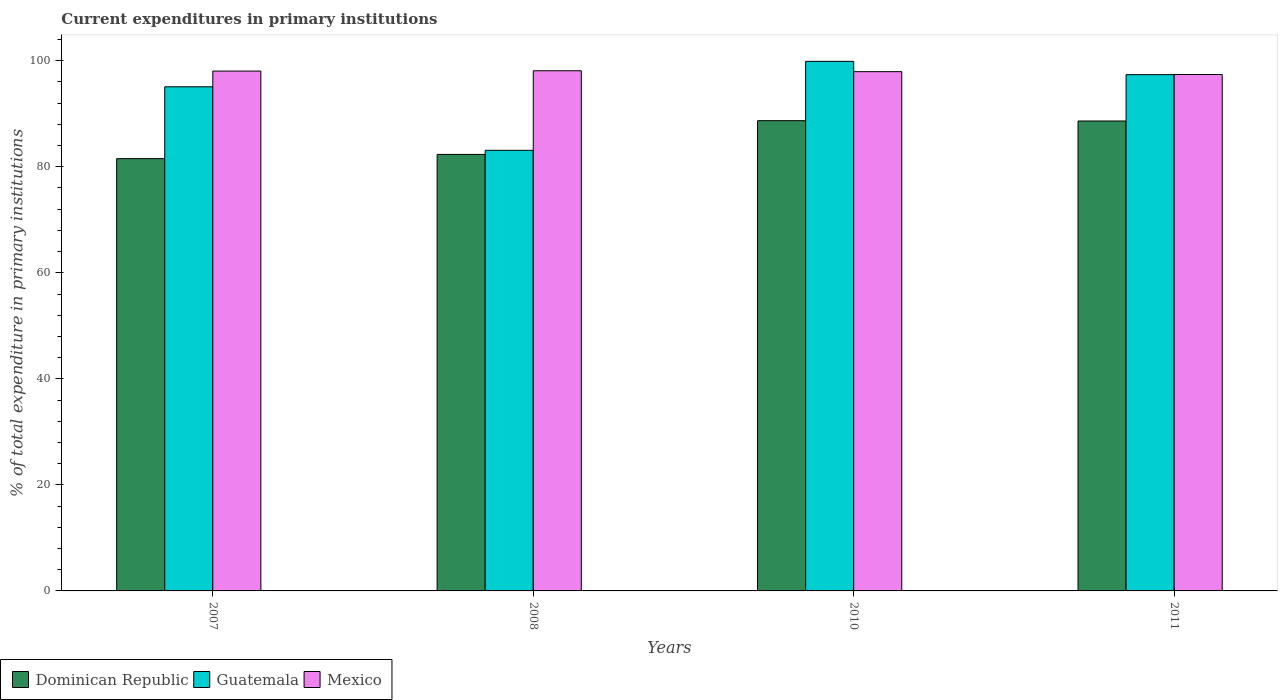How many different coloured bars are there?
Provide a short and direct response. 3. How many groups of bars are there?
Your answer should be very brief. 4. How many bars are there on the 1st tick from the left?
Provide a short and direct response. 3. What is the current expenditures in primary institutions in Guatemala in 2007?
Offer a terse response. 95.09. Across all years, what is the maximum current expenditures in primary institutions in Mexico?
Your answer should be compact. 98.11. Across all years, what is the minimum current expenditures in primary institutions in Mexico?
Keep it short and to the point. 97.4. In which year was the current expenditures in primary institutions in Dominican Republic maximum?
Provide a short and direct response. 2010. What is the total current expenditures in primary institutions in Guatemala in the graph?
Ensure brevity in your answer.  375.46. What is the difference between the current expenditures in primary institutions in Dominican Republic in 2008 and that in 2010?
Ensure brevity in your answer.  -6.36. What is the difference between the current expenditures in primary institutions in Mexico in 2007 and the current expenditures in primary institutions in Guatemala in 2010?
Ensure brevity in your answer.  -1.83. What is the average current expenditures in primary institutions in Dominican Republic per year?
Provide a short and direct response. 85.3. In the year 2008, what is the difference between the current expenditures in primary institutions in Mexico and current expenditures in primary institutions in Dominican Republic?
Make the answer very short. 15.78. In how many years, is the current expenditures in primary institutions in Dominican Republic greater than 76 %?
Provide a succinct answer. 4. What is the ratio of the current expenditures in primary institutions in Mexico in 2010 to that in 2011?
Your response must be concise. 1.01. Is the current expenditures in primary institutions in Guatemala in 2007 less than that in 2008?
Your answer should be compact. No. Is the difference between the current expenditures in primary institutions in Mexico in 2007 and 2011 greater than the difference between the current expenditures in primary institutions in Dominican Republic in 2007 and 2011?
Your answer should be compact. Yes. What is the difference between the highest and the second highest current expenditures in primary institutions in Guatemala?
Provide a short and direct response. 2.51. What is the difference between the highest and the lowest current expenditures in primary institutions in Dominican Republic?
Offer a terse response. 7.16. Is the sum of the current expenditures in primary institutions in Guatemala in 2007 and 2008 greater than the maximum current expenditures in primary institutions in Dominican Republic across all years?
Make the answer very short. Yes. What does the 1st bar from the left in 2008 represents?
Ensure brevity in your answer.  Dominican Republic. What does the 3rd bar from the right in 2011 represents?
Your answer should be very brief. Dominican Republic. Are all the bars in the graph horizontal?
Keep it short and to the point. No. How many years are there in the graph?
Provide a short and direct response. 4. Are the values on the major ticks of Y-axis written in scientific E-notation?
Offer a very short reply. No. Where does the legend appear in the graph?
Ensure brevity in your answer.  Bottom left. How are the legend labels stacked?
Give a very brief answer. Horizontal. What is the title of the graph?
Offer a terse response. Current expenditures in primary institutions. Does "Equatorial Guinea" appear as one of the legend labels in the graph?
Provide a succinct answer. No. What is the label or title of the Y-axis?
Provide a short and direct response. % of total expenditure in primary institutions. What is the % of total expenditure in primary institutions in Dominican Republic in 2007?
Your answer should be compact. 81.54. What is the % of total expenditure in primary institutions of Guatemala in 2007?
Make the answer very short. 95.09. What is the % of total expenditure in primary institutions of Mexico in 2007?
Give a very brief answer. 98.05. What is the % of total expenditure in primary institutions of Dominican Republic in 2008?
Provide a succinct answer. 82.33. What is the % of total expenditure in primary institutions in Guatemala in 2008?
Offer a very short reply. 83.11. What is the % of total expenditure in primary institutions of Mexico in 2008?
Your answer should be very brief. 98.11. What is the % of total expenditure in primary institutions in Dominican Republic in 2010?
Offer a terse response. 88.69. What is the % of total expenditure in primary institutions in Guatemala in 2010?
Ensure brevity in your answer.  99.89. What is the % of total expenditure in primary institutions in Mexico in 2010?
Your response must be concise. 97.94. What is the % of total expenditure in primary institutions in Dominican Republic in 2011?
Provide a succinct answer. 88.63. What is the % of total expenditure in primary institutions in Guatemala in 2011?
Your response must be concise. 97.38. What is the % of total expenditure in primary institutions in Mexico in 2011?
Your response must be concise. 97.4. Across all years, what is the maximum % of total expenditure in primary institutions of Dominican Republic?
Offer a very short reply. 88.69. Across all years, what is the maximum % of total expenditure in primary institutions in Guatemala?
Your answer should be very brief. 99.89. Across all years, what is the maximum % of total expenditure in primary institutions of Mexico?
Make the answer very short. 98.11. Across all years, what is the minimum % of total expenditure in primary institutions of Dominican Republic?
Your answer should be very brief. 81.54. Across all years, what is the minimum % of total expenditure in primary institutions of Guatemala?
Offer a very short reply. 83.11. Across all years, what is the minimum % of total expenditure in primary institutions in Mexico?
Offer a very short reply. 97.4. What is the total % of total expenditure in primary institutions in Dominican Republic in the graph?
Make the answer very short. 341.2. What is the total % of total expenditure in primary institutions of Guatemala in the graph?
Offer a very short reply. 375.46. What is the total % of total expenditure in primary institutions of Mexico in the graph?
Offer a terse response. 391.51. What is the difference between the % of total expenditure in primary institutions in Dominican Republic in 2007 and that in 2008?
Ensure brevity in your answer.  -0.8. What is the difference between the % of total expenditure in primary institutions of Guatemala in 2007 and that in 2008?
Your answer should be very brief. 11.98. What is the difference between the % of total expenditure in primary institutions in Mexico in 2007 and that in 2008?
Ensure brevity in your answer.  -0.06. What is the difference between the % of total expenditure in primary institutions of Dominican Republic in 2007 and that in 2010?
Offer a very short reply. -7.16. What is the difference between the % of total expenditure in primary institutions in Guatemala in 2007 and that in 2010?
Your answer should be very brief. -4.8. What is the difference between the % of total expenditure in primary institutions in Mexico in 2007 and that in 2010?
Make the answer very short. 0.11. What is the difference between the % of total expenditure in primary institutions of Dominican Republic in 2007 and that in 2011?
Make the answer very short. -7.1. What is the difference between the % of total expenditure in primary institutions in Guatemala in 2007 and that in 2011?
Ensure brevity in your answer.  -2.29. What is the difference between the % of total expenditure in primary institutions in Mexico in 2007 and that in 2011?
Make the answer very short. 0.65. What is the difference between the % of total expenditure in primary institutions of Dominican Republic in 2008 and that in 2010?
Keep it short and to the point. -6.36. What is the difference between the % of total expenditure in primary institutions of Guatemala in 2008 and that in 2010?
Offer a very short reply. -16.78. What is the difference between the % of total expenditure in primary institutions of Mexico in 2008 and that in 2010?
Keep it short and to the point. 0.17. What is the difference between the % of total expenditure in primary institutions of Dominican Republic in 2008 and that in 2011?
Ensure brevity in your answer.  -6.3. What is the difference between the % of total expenditure in primary institutions in Guatemala in 2008 and that in 2011?
Your answer should be compact. -14.27. What is the difference between the % of total expenditure in primary institutions of Mexico in 2008 and that in 2011?
Provide a succinct answer. 0.71. What is the difference between the % of total expenditure in primary institutions of Dominican Republic in 2010 and that in 2011?
Offer a very short reply. 0.06. What is the difference between the % of total expenditure in primary institutions in Guatemala in 2010 and that in 2011?
Your response must be concise. 2.51. What is the difference between the % of total expenditure in primary institutions of Mexico in 2010 and that in 2011?
Your answer should be very brief. 0.54. What is the difference between the % of total expenditure in primary institutions in Dominican Republic in 2007 and the % of total expenditure in primary institutions in Guatemala in 2008?
Provide a succinct answer. -1.57. What is the difference between the % of total expenditure in primary institutions in Dominican Republic in 2007 and the % of total expenditure in primary institutions in Mexico in 2008?
Provide a short and direct response. -16.58. What is the difference between the % of total expenditure in primary institutions in Guatemala in 2007 and the % of total expenditure in primary institutions in Mexico in 2008?
Your answer should be very brief. -3.02. What is the difference between the % of total expenditure in primary institutions of Dominican Republic in 2007 and the % of total expenditure in primary institutions of Guatemala in 2010?
Provide a short and direct response. -18.35. What is the difference between the % of total expenditure in primary institutions of Dominican Republic in 2007 and the % of total expenditure in primary institutions of Mexico in 2010?
Your response must be concise. -16.41. What is the difference between the % of total expenditure in primary institutions in Guatemala in 2007 and the % of total expenditure in primary institutions in Mexico in 2010?
Your answer should be very brief. -2.85. What is the difference between the % of total expenditure in primary institutions of Dominican Republic in 2007 and the % of total expenditure in primary institutions of Guatemala in 2011?
Keep it short and to the point. -15.84. What is the difference between the % of total expenditure in primary institutions of Dominican Republic in 2007 and the % of total expenditure in primary institutions of Mexico in 2011?
Your answer should be compact. -15.87. What is the difference between the % of total expenditure in primary institutions in Guatemala in 2007 and the % of total expenditure in primary institutions in Mexico in 2011?
Offer a very short reply. -2.32. What is the difference between the % of total expenditure in primary institutions in Dominican Republic in 2008 and the % of total expenditure in primary institutions in Guatemala in 2010?
Ensure brevity in your answer.  -17.55. What is the difference between the % of total expenditure in primary institutions of Dominican Republic in 2008 and the % of total expenditure in primary institutions of Mexico in 2010?
Provide a short and direct response. -15.61. What is the difference between the % of total expenditure in primary institutions of Guatemala in 2008 and the % of total expenditure in primary institutions of Mexico in 2010?
Offer a very short reply. -14.84. What is the difference between the % of total expenditure in primary institutions of Dominican Republic in 2008 and the % of total expenditure in primary institutions of Guatemala in 2011?
Offer a terse response. -15.05. What is the difference between the % of total expenditure in primary institutions of Dominican Republic in 2008 and the % of total expenditure in primary institutions of Mexico in 2011?
Provide a short and direct response. -15.07. What is the difference between the % of total expenditure in primary institutions in Guatemala in 2008 and the % of total expenditure in primary institutions in Mexico in 2011?
Offer a terse response. -14.3. What is the difference between the % of total expenditure in primary institutions in Dominican Republic in 2010 and the % of total expenditure in primary institutions in Guatemala in 2011?
Your response must be concise. -8.68. What is the difference between the % of total expenditure in primary institutions in Dominican Republic in 2010 and the % of total expenditure in primary institutions in Mexico in 2011?
Your answer should be compact. -8.71. What is the difference between the % of total expenditure in primary institutions of Guatemala in 2010 and the % of total expenditure in primary institutions of Mexico in 2011?
Offer a very short reply. 2.48. What is the average % of total expenditure in primary institutions of Dominican Republic per year?
Your answer should be very brief. 85.3. What is the average % of total expenditure in primary institutions in Guatemala per year?
Keep it short and to the point. 93.86. What is the average % of total expenditure in primary institutions of Mexico per year?
Keep it short and to the point. 97.88. In the year 2007, what is the difference between the % of total expenditure in primary institutions of Dominican Republic and % of total expenditure in primary institutions of Guatemala?
Offer a terse response. -13.55. In the year 2007, what is the difference between the % of total expenditure in primary institutions in Dominican Republic and % of total expenditure in primary institutions in Mexico?
Ensure brevity in your answer.  -16.52. In the year 2007, what is the difference between the % of total expenditure in primary institutions in Guatemala and % of total expenditure in primary institutions in Mexico?
Keep it short and to the point. -2.96. In the year 2008, what is the difference between the % of total expenditure in primary institutions of Dominican Republic and % of total expenditure in primary institutions of Guatemala?
Ensure brevity in your answer.  -0.77. In the year 2008, what is the difference between the % of total expenditure in primary institutions of Dominican Republic and % of total expenditure in primary institutions of Mexico?
Ensure brevity in your answer.  -15.78. In the year 2008, what is the difference between the % of total expenditure in primary institutions of Guatemala and % of total expenditure in primary institutions of Mexico?
Offer a very short reply. -15.01. In the year 2010, what is the difference between the % of total expenditure in primary institutions in Dominican Republic and % of total expenditure in primary institutions in Guatemala?
Offer a terse response. -11.19. In the year 2010, what is the difference between the % of total expenditure in primary institutions in Dominican Republic and % of total expenditure in primary institutions in Mexico?
Your answer should be compact. -9.25. In the year 2010, what is the difference between the % of total expenditure in primary institutions in Guatemala and % of total expenditure in primary institutions in Mexico?
Ensure brevity in your answer.  1.94. In the year 2011, what is the difference between the % of total expenditure in primary institutions in Dominican Republic and % of total expenditure in primary institutions in Guatemala?
Provide a succinct answer. -8.74. In the year 2011, what is the difference between the % of total expenditure in primary institutions of Dominican Republic and % of total expenditure in primary institutions of Mexico?
Your answer should be compact. -8.77. In the year 2011, what is the difference between the % of total expenditure in primary institutions in Guatemala and % of total expenditure in primary institutions in Mexico?
Your answer should be very brief. -0.02. What is the ratio of the % of total expenditure in primary institutions in Dominican Republic in 2007 to that in 2008?
Your response must be concise. 0.99. What is the ratio of the % of total expenditure in primary institutions of Guatemala in 2007 to that in 2008?
Give a very brief answer. 1.14. What is the ratio of the % of total expenditure in primary institutions of Mexico in 2007 to that in 2008?
Provide a short and direct response. 1. What is the ratio of the % of total expenditure in primary institutions of Dominican Republic in 2007 to that in 2010?
Give a very brief answer. 0.92. What is the ratio of the % of total expenditure in primary institutions in Guatemala in 2007 to that in 2010?
Offer a terse response. 0.95. What is the ratio of the % of total expenditure in primary institutions of Dominican Republic in 2007 to that in 2011?
Ensure brevity in your answer.  0.92. What is the ratio of the % of total expenditure in primary institutions in Guatemala in 2007 to that in 2011?
Provide a succinct answer. 0.98. What is the ratio of the % of total expenditure in primary institutions in Mexico in 2007 to that in 2011?
Offer a very short reply. 1.01. What is the ratio of the % of total expenditure in primary institutions in Dominican Republic in 2008 to that in 2010?
Offer a terse response. 0.93. What is the ratio of the % of total expenditure in primary institutions of Guatemala in 2008 to that in 2010?
Your response must be concise. 0.83. What is the ratio of the % of total expenditure in primary institutions in Dominican Republic in 2008 to that in 2011?
Your answer should be very brief. 0.93. What is the ratio of the % of total expenditure in primary institutions of Guatemala in 2008 to that in 2011?
Provide a succinct answer. 0.85. What is the ratio of the % of total expenditure in primary institutions in Mexico in 2008 to that in 2011?
Provide a short and direct response. 1.01. What is the ratio of the % of total expenditure in primary institutions in Dominican Republic in 2010 to that in 2011?
Offer a very short reply. 1. What is the ratio of the % of total expenditure in primary institutions of Guatemala in 2010 to that in 2011?
Provide a succinct answer. 1.03. What is the difference between the highest and the second highest % of total expenditure in primary institutions in Dominican Republic?
Provide a short and direct response. 0.06. What is the difference between the highest and the second highest % of total expenditure in primary institutions of Guatemala?
Give a very brief answer. 2.51. What is the difference between the highest and the second highest % of total expenditure in primary institutions in Mexico?
Make the answer very short. 0.06. What is the difference between the highest and the lowest % of total expenditure in primary institutions of Dominican Republic?
Provide a short and direct response. 7.16. What is the difference between the highest and the lowest % of total expenditure in primary institutions in Guatemala?
Your response must be concise. 16.78. What is the difference between the highest and the lowest % of total expenditure in primary institutions of Mexico?
Your answer should be compact. 0.71. 